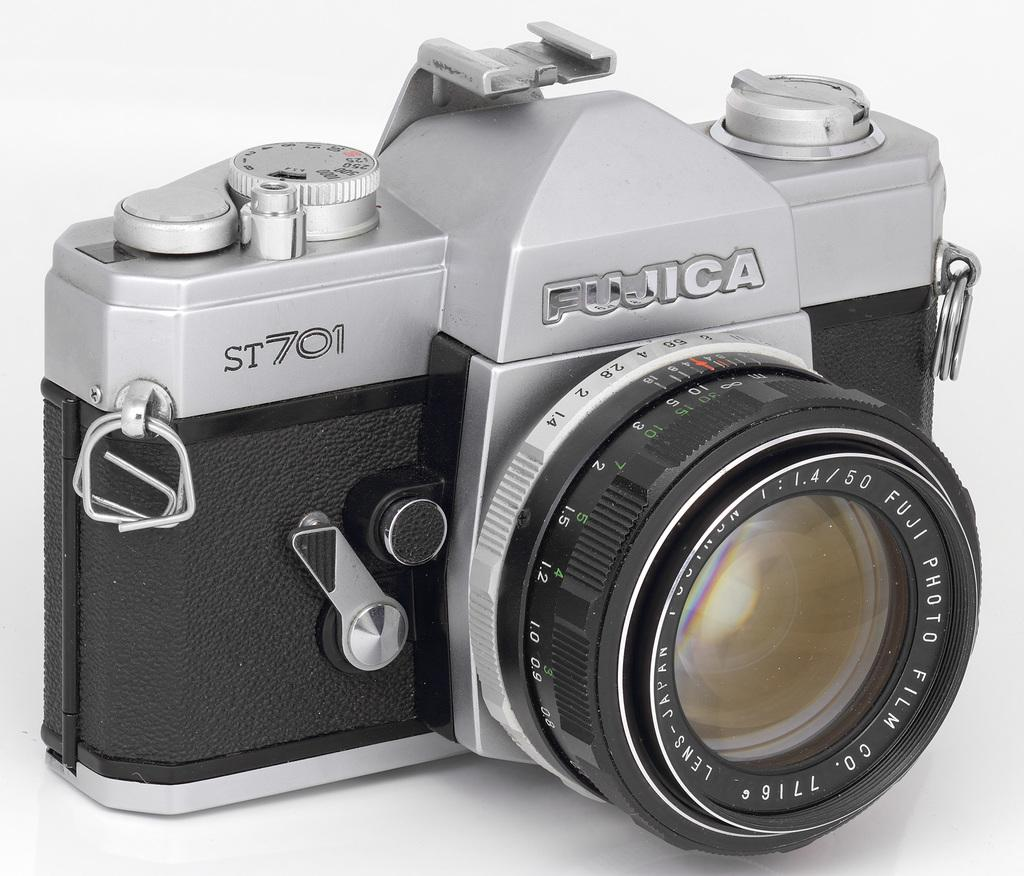Provide a one-sentence caption for the provided image. A silver and black camera displaying the brand name Fujica. 